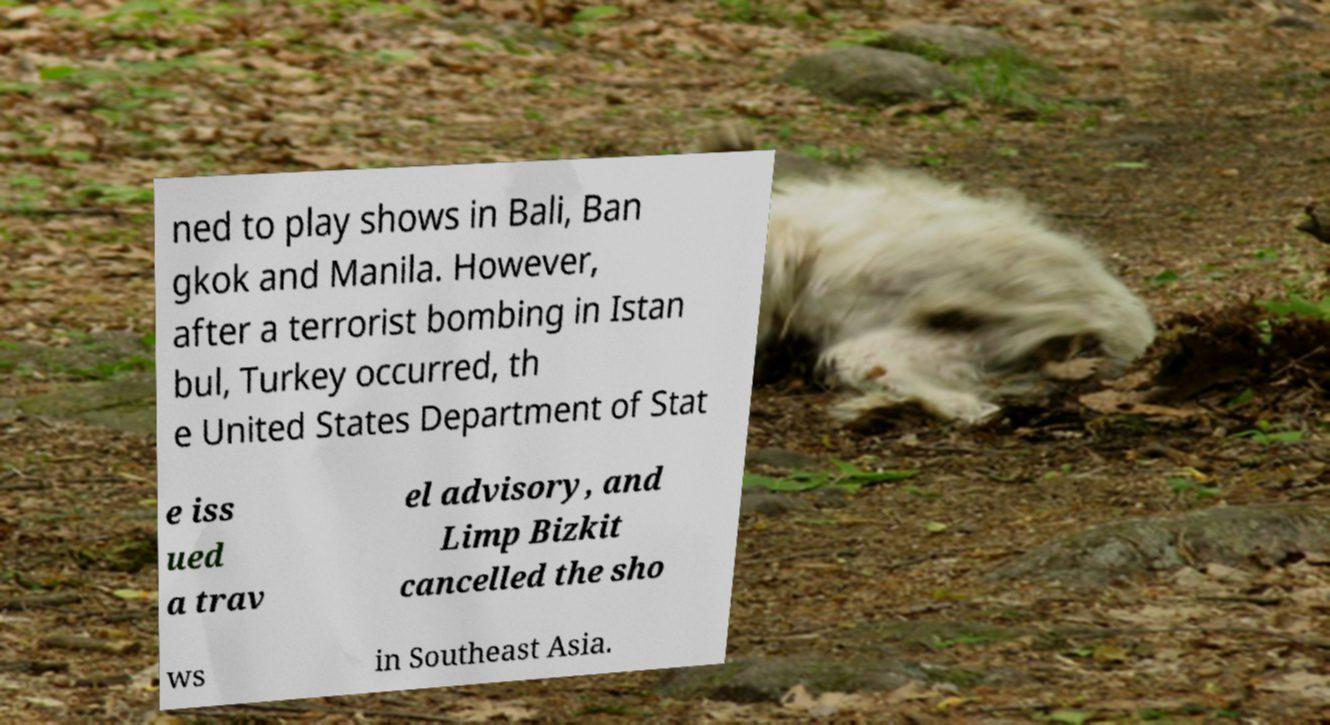There's text embedded in this image that I need extracted. Can you transcribe it verbatim? ned to play shows in Bali, Ban gkok and Manila. However, after a terrorist bombing in Istan bul, Turkey occurred, th e United States Department of Stat e iss ued a trav el advisory, and Limp Bizkit cancelled the sho ws in Southeast Asia. 